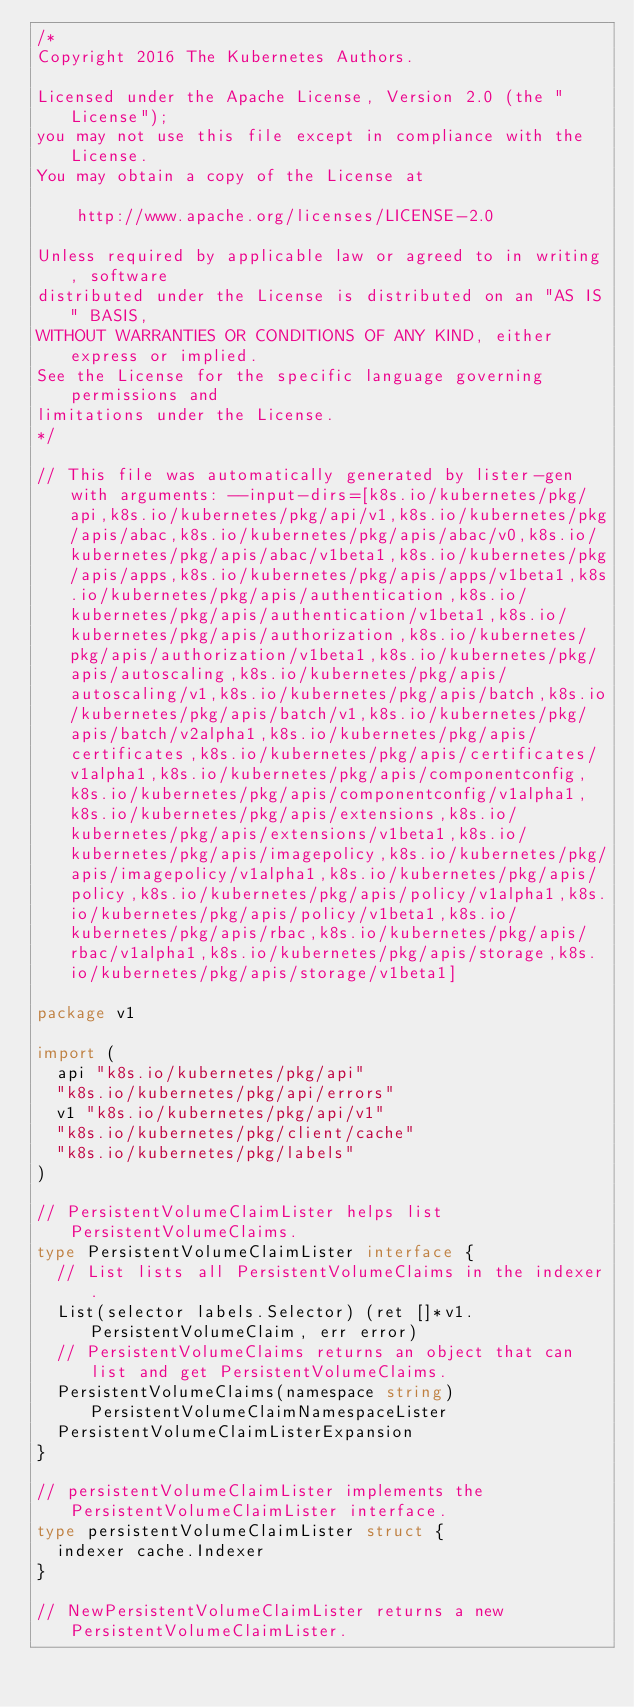<code> <loc_0><loc_0><loc_500><loc_500><_Go_>/*
Copyright 2016 The Kubernetes Authors.

Licensed under the Apache License, Version 2.0 (the "License");
you may not use this file except in compliance with the License.
You may obtain a copy of the License at

    http://www.apache.org/licenses/LICENSE-2.0

Unless required by applicable law or agreed to in writing, software
distributed under the License is distributed on an "AS IS" BASIS,
WITHOUT WARRANTIES OR CONDITIONS OF ANY KIND, either express or implied.
See the License for the specific language governing permissions and
limitations under the License.
*/

// This file was automatically generated by lister-gen with arguments: --input-dirs=[k8s.io/kubernetes/pkg/api,k8s.io/kubernetes/pkg/api/v1,k8s.io/kubernetes/pkg/apis/abac,k8s.io/kubernetes/pkg/apis/abac/v0,k8s.io/kubernetes/pkg/apis/abac/v1beta1,k8s.io/kubernetes/pkg/apis/apps,k8s.io/kubernetes/pkg/apis/apps/v1beta1,k8s.io/kubernetes/pkg/apis/authentication,k8s.io/kubernetes/pkg/apis/authentication/v1beta1,k8s.io/kubernetes/pkg/apis/authorization,k8s.io/kubernetes/pkg/apis/authorization/v1beta1,k8s.io/kubernetes/pkg/apis/autoscaling,k8s.io/kubernetes/pkg/apis/autoscaling/v1,k8s.io/kubernetes/pkg/apis/batch,k8s.io/kubernetes/pkg/apis/batch/v1,k8s.io/kubernetes/pkg/apis/batch/v2alpha1,k8s.io/kubernetes/pkg/apis/certificates,k8s.io/kubernetes/pkg/apis/certificates/v1alpha1,k8s.io/kubernetes/pkg/apis/componentconfig,k8s.io/kubernetes/pkg/apis/componentconfig/v1alpha1,k8s.io/kubernetes/pkg/apis/extensions,k8s.io/kubernetes/pkg/apis/extensions/v1beta1,k8s.io/kubernetes/pkg/apis/imagepolicy,k8s.io/kubernetes/pkg/apis/imagepolicy/v1alpha1,k8s.io/kubernetes/pkg/apis/policy,k8s.io/kubernetes/pkg/apis/policy/v1alpha1,k8s.io/kubernetes/pkg/apis/policy/v1beta1,k8s.io/kubernetes/pkg/apis/rbac,k8s.io/kubernetes/pkg/apis/rbac/v1alpha1,k8s.io/kubernetes/pkg/apis/storage,k8s.io/kubernetes/pkg/apis/storage/v1beta1]

package v1

import (
	api "k8s.io/kubernetes/pkg/api"
	"k8s.io/kubernetes/pkg/api/errors"
	v1 "k8s.io/kubernetes/pkg/api/v1"
	"k8s.io/kubernetes/pkg/client/cache"
	"k8s.io/kubernetes/pkg/labels"
)

// PersistentVolumeClaimLister helps list PersistentVolumeClaims.
type PersistentVolumeClaimLister interface {
	// List lists all PersistentVolumeClaims in the indexer.
	List(selector labels.Selector) (ret []*v1.PersistentVolumeClaim, err error)
	// PersistentVolumeClaims returns an object that can list and get PersistentVolumeClaims.
	PersistentVolumeClaims(namespace string) PersistentVolumeClaimNamespaceLister
	PersistentVolumeClaimListerExpansion
}

// persistentVolumeClaimLister implements the PersistentVolumeClaimLister interface.
type persistentVolumeClaimLister struct {
	indexer cache.Indexer
}

// NewPersistentVolumeClaimLister returns a new PersistentVolumeClaimLister.</code> 